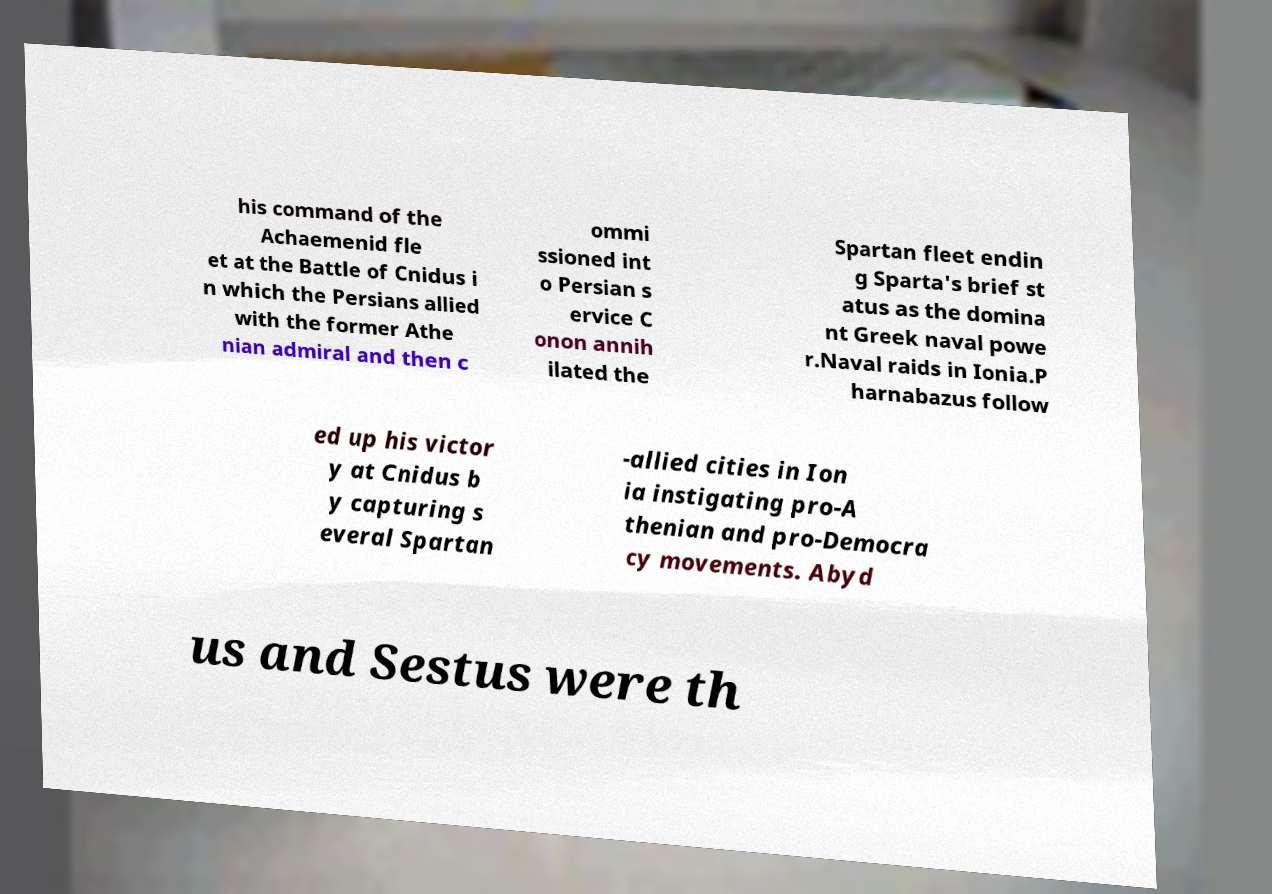For documentation purposes, I need the text within this image transcribed. Could you provide that? his command of the Achaemenid fle et at the Battle of Cnidus i n which the Persians allied with the former Athe nian admiral and then c ommi ssioned int o Persian s ervice C onon annih ilated the Spartan fleet endin g Sparta's brief st atus as the domina nt Greek naval powe r.Naval raids in Ionia.P harnabazus follow ed up his victor y at Cnidus b y capturing s everal Spartan -allied cities in Ion ia instigating pro-A thenian and pro-Democra cy movements. Abyd us and Sestus were th 